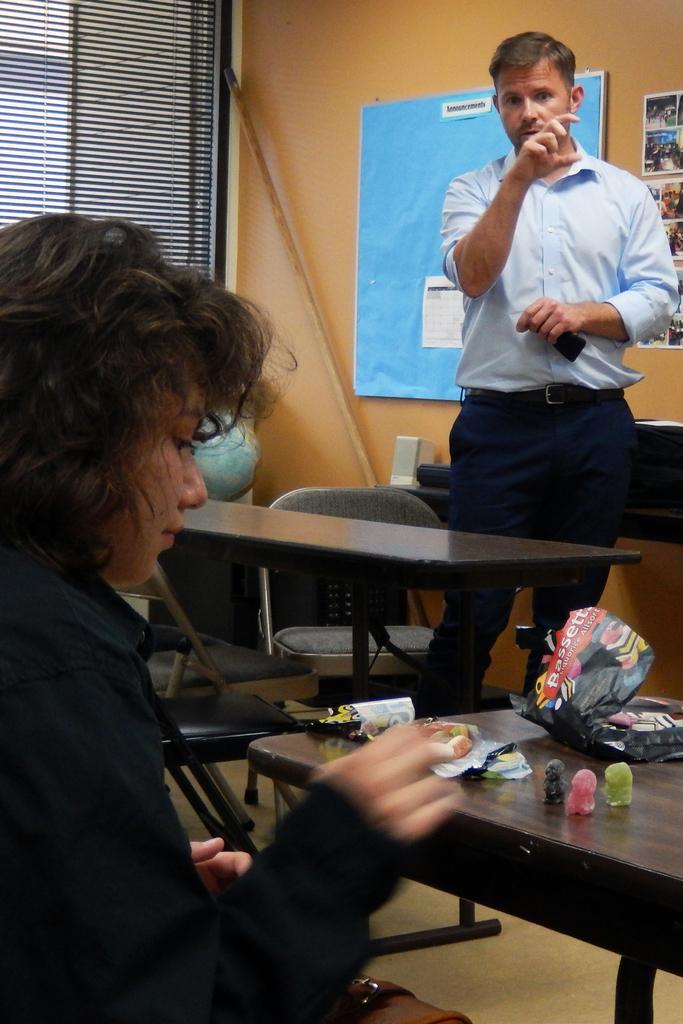Could you give a brief overview of what you see in this image? This image is clicked in a room. There is window blind on the top left corner. There is a board in the middle to the wall. There are two persons in this image left side there is women ,right there is men and there are tables here. Women placed something on the tables. There also chairs in this image. 